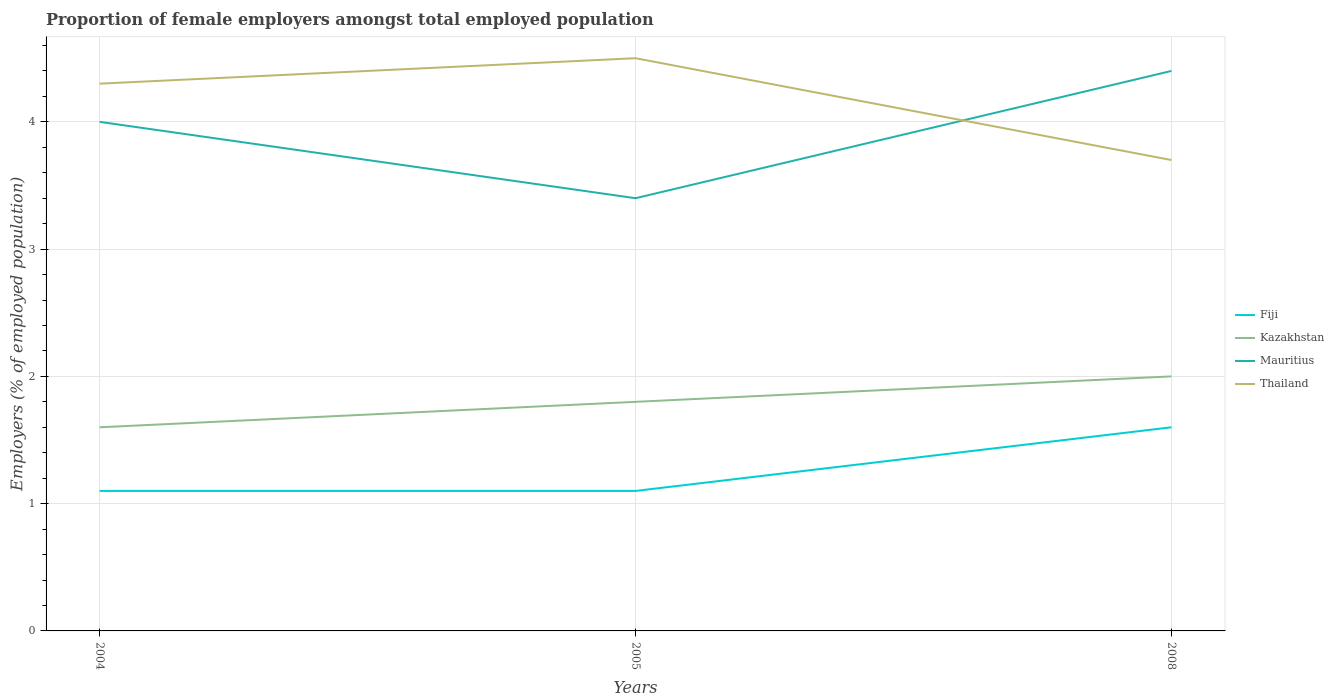How many different coloured lines are there?
Ensure brevity in your answer.  4. Does the line corresponding to Thailand intersect with the line corresponding to Kazakhstan?
Offer a very short reply. No. Across all years, what is the maximum proportion of female employers in Fiji?
Your response must be concise. 1.1. What is the total proportion of female employers in Thailand in the graph?
Offer a terse response. 0.6. What is the difference between the highest and the second highest proportion of female employers in Kazakhstan?
Your answer should be compact. 0.4. What is the difference between the highest and the lowest proportion of female employers in Mauritius?
Ensure brevity in your answer.  2. How many lines are there?
Provide a succinct answer. 4. Does the graph contain any zero values?
Ensure brevity in your answer.  No. How are the legend labels stacked?
Ensure brevity in your answer.  Vertical. What is the title of the graph?
Your answer should be very brief. Proportion of female employers amongst total employed population. Does "Mali" appear as one of the legend labels in the graph?
Offer a terse response. No. What is the label or title of the X-axis?
Make the answer very short. Years. What is the label or title of the Y-axis?
Offer a very short reply. Employers (% of employed population). What is the Employers (% of employed population) of Fiji in 2004?
Your answer should be compact. 1.1. What is the Employers (% of employed population) in Kazakhstan in 2004?
Keep it short and to the point. 1.6. What is the Employers (% of employed population) in Mauritius in 2004?
Offer a very short reply. 4. What is the Employers (% of employed population) in Thailand in 2004?
Your answer should be very brief. 4.3. What is the Employers (% of employed population) in Fiji in 2005?
Offer a terse response. 1.1. What is the Employers (% of employed population) in Kazakhstan in 2005?
Offer a terse response. 1.8. What is the Employers (% of employed population) of Mauritius in 2005?
Make the answer very short. 3.4. What is the Employers (% of employed population) in Fiji in 2008?
Keep it short and to the point. 1.6. What is the Employers (% of employed population) in Mauritius in 2008?
Provide a short and direct response. 4.4. What is the Employers (% of employed population) in Thailand in 2008?
Ensure brevity in your answer.  3.7. Across all years, what is the maximum Employers (% of employed population) in Fiji?
Provide a succinct answer. 1.6. Across all years, what is the maximum Employers (% of employed population) in Kazakhstan?
Your answer should be compact. 2. Across all years, what is the maximum Employers (% of employed population) in Mauritius?
Provide a succinct answer. 4.4. Across all years, what is the minimum Employers (% of employed population) in Fiji?
Give a very brief answer. 1.1. Across all years, what is the minimum Employers (% of employed population) in Kazakhstan?
Your answer should be compact. 1.6. Across all years, what is the minimum Employers (% of employed population) in Mauritius?
Give a very brief answer. 3.4. Across all years, what is the minimum Employers (% of employed population) of Thailand?
Make the answer very short. 3.7. What is the total Employers (% of employed population) of Mauritius in the graph?
Offer a very short reply. 11.8. What is the difference between the Employers (% of employed population) of Kazakhstan in 2004 and that in 2005?
Ensure brevity in your answer.  -0.2. What is the difference between the Employers (% of employed population) in Thailand in 2004 and that in 2008?
Make the answer very short. 0.6. What is the difference between the Employers (% of employed population) of Fiji in 2005 and that in 2008?
Ensure brevity in your answer.  -0.5. What is the difference between the Employers (% of employed population) of Fiji in 2004 and the Employers (% of employed population) of Kazakhstan in 2005?
Offer a very short reply. -0.7. What is the difference between the Employers (% of employed population) of Kazakhstan in 2004 and the Employers (% of employed population) of Mauritius in 2005?
Provide a succinct answer. -1.8. What is the difference between the Employers (% of employed population) of Kazakhstan in 2004 and the Employers (% of employed population) of Thailand in 2005?
Offer a terse response. -2.9. What is the difference between the Employers (% of employed population) in Fiji in 2004 and the Employers (% of employed population) in Kazakhstan in 2008?
Your answer should be very brief. -0.9. What is the difference between the Employers (% of employed population) of Kazakhstan in 2004 and the Employers (% of employed population) of Thailand in 2008?
Offer a very short reply. -2.1. What is the difference between the Employers (% of employed population) of Mauritius in 2004 and the Employers (% of employed population) of Thailand in 2008?
Ensure brevity in your answer.  0.3. What is the difference between the Employers (% of employed population) of Fiji in 2005 and the Employers (% of employed population) of Thailand in 2008?
Keep it short and to the point. -2.6. What is the difference between the Employers (% of employed population) of Mauritius in 2005 and the Employers (% of employed population) of Thailand in 2008?
Provide a short and direct response. -0.3. What is the average Employers (% of employed population) of Fiji per year?
Give a very brief answer. 1.27. What is the average Employers (% of employed population) of Mauritius per year?
Offer a terse response. 3.93. What is the average Employers (% of employed population) in Thailand per year?
Make the answer very short. 4.17. In the year 2004, what is the difference between the Employers (% of employed population) in Fiji and Employers (% of employed population) in Mauritius?
Offer a very short reply. -2.9. In the year 2004, what is the difference between the Employers (% of employed population) in Fiji and Employers (% of employed population) in Thailand?
Your answer should be compact. -3.2. In the year 2004, what is the difference between the Employers (% of employed population) of Mauritius and Employers (% of employed population) of Thailand?
Keep it short and to the point. -0.3. In the year 2005, what is the difference between the Employers (% of employed population) of Fiji and Employers (% of employed population) of Kazakhstan?
Offer a very short reply. -0.7. In the year 2005, what is the difference between the Employers (% of employed population) of Fiji and Employers (% of employed population) of Mauritius?
Offer a very short reply. -2.3. In the year 2005, what is the difference between the Employers (% of employed population) of Fiji and Employers (% of employed population) of Thailand?
Give a very brief answer. -3.4. In the year 2005, what is the difference between the Employers (% of employed population) in Kazakhstan and Employers (% of employed population) in Thailand?
Make the answer very short. -2.7. In the year 2008, what is the difference between the Employers (% of employed population) in Kazakhstan and Employers (% of employed population) in Mauritius?
Offer a terse response. -2.4. What is the ratio of the Employers (% of employed population) of Mauritius in 2004 to that in 2005?
Offer a terse response. 1.18. What is the ratio of the Employers (% of employed population) of Thailand in 2004 to that in 2005?
Offer a very short reply. 0.96. What is the ratio of the Employers (% of employed population) of Fiji in 2004 to that in 2008?
Ensure brevity in your answer.  0.69. What is the ratio of the Employers (% of employed population) in Thailand in 2004 to that in 2008?
Provide a succinct answer. 1.16. What is the ratio of the Employers (% of employed population) in Fiji in 2005 to that in 2008?
Keep it short and to the point. 0.69. What is the ratio of the Employers (% of employed population) of Kazakhstan in 2005 to that in 2008?
Make the answer very short. 0.9. What is the ratio of the Employers (% of employed population) in Mauritius in 2005 to that in 2008?
Provide a succinct answer. 0.77. What is the ratio of the Employers (% of employed population) in Thailand in 2005 to that in 2008?
Keep it short and to the point. 1.22. What is the difference between the highest and the second highest Employers (% of employed population) of Fiji?
Offer a very short reply. 0.5. What is the difference between the highest and the second highest Employers (% of employed population) of Kazakhstan?
Your answer should be compact. 0.2. What is the difference between the highest and the second highest Employers (% of employed population) in Mauritius?
Provide a succinct answer. 0.4. What is the difference between the highest and the lowest Employers (% of employed population) in Fiji?
Your response must be concise. 0.5. What is the difference between the highest and the lowest Employers (% of employed population) in Kazakhstan?
Offer a very short reply. 0.4. What is the difference between the highest and the lowest Employers (% of employed population) of Thailand?
Provide a short and direct response. 0.8. 